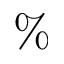<formula> <loc_0><loc_0><loc_500><loc_500>\%</formula> 